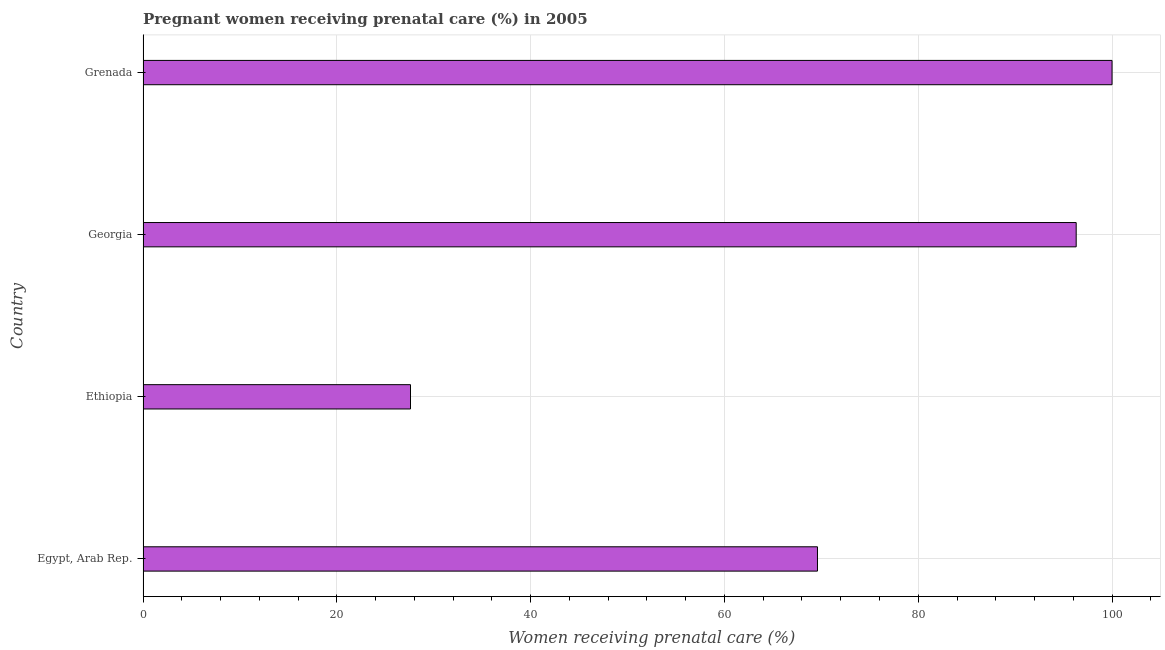What is the title of the graph?
Give a very brief answer. Pregnant women receiving prenatal care (%) in 2005. What is the label or title of the X-axis?
Offer a terse response. Women receiving prenatal care (%). Across all countries, what is the maximum percentage of pregnant women receiving prenatal care?
Give a very brief answer. 100. Across all countries, what is the minimum percentage of pregnant women receiving prenatal care?
Provide a short and direct response. 27.6. In which country was the percentage of pregnant women receiving prenatal care maximum?
Offer a very short reply. Grenada. In which country was the percentage of pregnant women receiving prenatal care minimum?
Offer a terse response. Ethiopia. What is the sum of the percentage of pregnant women receiving prenatal care?
Make the answer very short. 293.5. What is the difference between the percentage of pregnant women receiving prenatal care in Egypt, Arab Rep. and Georgia?
Make the answer very short. -26.7. What is the average percentage of pregnant women receiving prenatal care per country?
Offer a very short reply. 73.38. What is the median percentage of pregnant women receiving prenatal care?
Provide a succinct answer. 82.95. In how many countries, is the percentage of pregnant women receiving prenatal care greater than 80 %?
Make the answer very short. 2. What is the ratio of the percentage of pregnant women receiving prenatal care in Egypt, Arab Rep. to that in Georgia?
Make the answer very short. 0.72. Is the difference between the percentage of pregnant women receiving prenatal care in Egypt, Arab Rep. and Georgia greater than the difference between any two countries?
Your answer should be very brief. No. What is the difference between the highest and the lowest percentage of pregnant women receiving prenatal care?
Your answer should be very brief. 72.4. In how many countries, is the percentage of pregnant women receiving prenatal care greater than the average percentage of pregnant women receiving prenatal care taken over all countries?
Give a very brief answer. 2. How many bars are there?
Your response must be concise. 4. Are all the bars in the graph horizontal?
Offer a terse response. Yes. What is the difference between two consecutive major ticks on the X-axis?
Make the answer very short. 20. Are the values on the major ticks of X-axis written in scientific E-notation?
Give a very brief answer. No. What is the Women receiving prenatal care (%) of Egypt, Arab Rep.?
Provide a short and direct response. 69.6. What is the Women receiving prenatal care (%) of Ethiopia?
Provide a short and direct response. 27.6. What is the Women receiving prenatal care (%) in Georgia?
Provide a succinct answer. 96.3. What is the Women receiving prenatal care (%) of Grenada?
Make the answer very short. 100. What is the difference between the Women receiving prenatal care (%) in Egypt, Arab Rep. and Ethiopia?
Your answer should be very brief. 42. What is the difference between the Women receiving prenatal care (%) in Egypt, Arab Rep. and Georgia?
Provide a short and direct response. -26.7. What is the difference between the Women receiving prenatal care (%) in Egypt, Arab Rep. and Grenada?
Your answer should be very brief. -30.4. What is the difference between the Women receiving prenatal care (%) in Ethiopia and Georgia?
Offer a very short reply. -68.7. What is the difference between the Women receiving prenatal care (%) in Ethiopia and Grenada?
Offer a terse response. -72.4. What is the ratio of the Women receiving prenatal care (%) in Egypt, Arab Rep. to that in Ethiopia?
Keep it short and to the point. 2.52. What is the ratio of the Women receiving prenatal care (%) in Egypt, Arab Rep. to that in Georgia?
Make the answer very short. 0.72. What is the ratio of the Women receiving prenatal care (%) in Egypt, Arab Rep. to that in Grenada?
Offer a terse response. 0.7. What is the ratio of the Women receiving prenatal care (%) in Ethiopia to that in Georgia?
Provide a succinct answer. 0.29. What is the ratio of the Women receiving prenatal care (%) in Ethiopia to that in Grenada?
Your response must be concise. 0.28. What is the ratio of the Women receiving prenatal care (%) in Georgia to that in Grenada?
Offer a terse response. 0.96. 